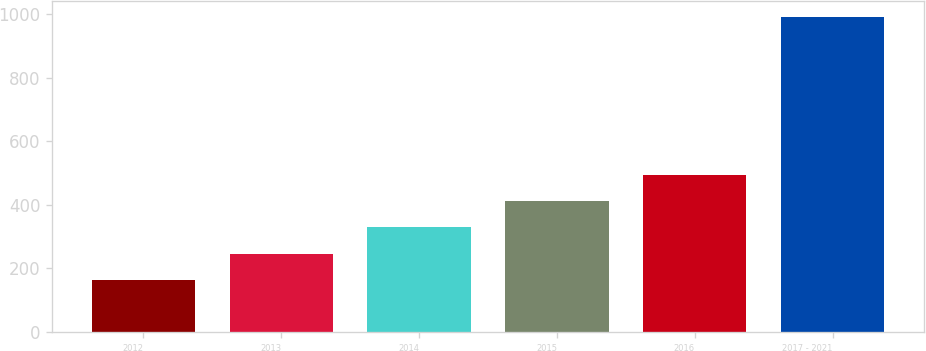<chart> <loc_0><loc_0><loc_500><loc_500><bar_chart><fcel>2012<fcel>2013<fcel>2014<fcel>2015<fcel>2016<fcel>2017 - 2021<nl><fcel>164<fcel>246.6<fcel>329.2<fcel>411.8<fcel>494.4<fcel>990<nl></chart> 